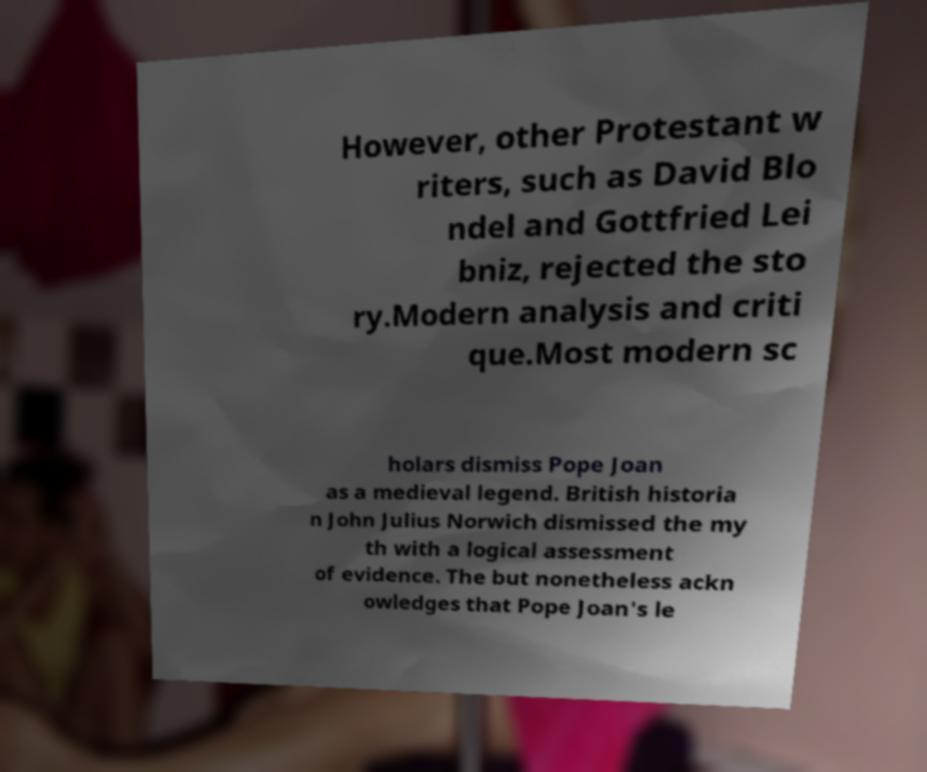Can you read and provide the text displayed in the image?This photo seems to have some interesting text. Can you extract and type it out for me? However, other Protestant w riters, such as David Blo ndel and Gottfried Lei bniz, rejected the sto ry.Modern analysis and criti que.Most modern sc holars dismiss Pope Joan as a medieval legend. British historia n John Julius Norwich dismissed the my th with a logical assessment of evidence. The but nonetheless ackn owledges that Pope Joan's le 